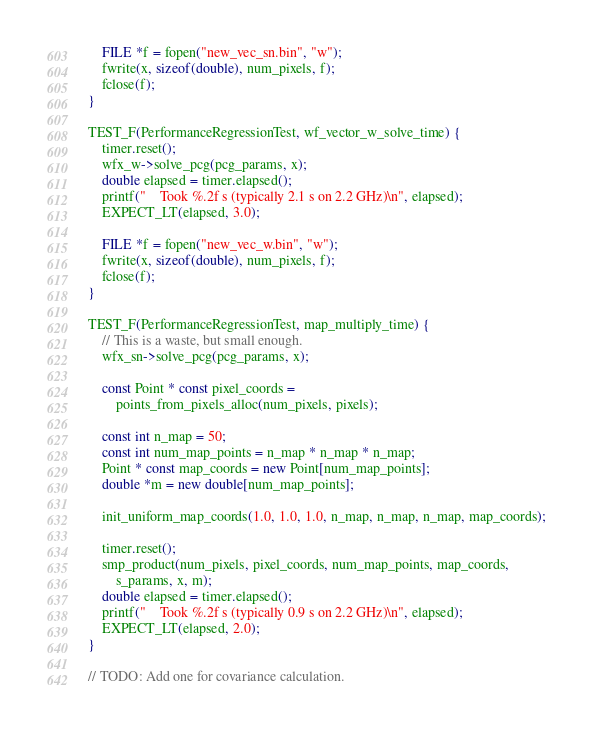<code> <loc_0><loc_0><loc_500><loc_500><_C++_>
    FILE *f = fopen("new_vec_sn.bin", "w");
    fwrite(x, sizeof(double), num_pixels, f);
    fclose(f);
}

TEST_F(PerformanceRegressionTest, wf_vector_w_solve_time) {
    timer.reset();
    wfx_w->solve_pcg(pcg_params, x);
    double elapsed = timer.elapsed();
    printf("    Took %.2f s (typically 2.1 s on 2.2 GHz)\n", elapsed);
    EXPECT_LT(elapsed, 3.0);

    FILE *f = fopen("new_vec_w.bin", "w");
    fwrite(x, sizeof(double), num_pixels, f);
    fclose(f);
}

TEST_F(PerformanceRegressionTest, map_multiply_time) {
    // This is a waste, but small enough.
    wfx_sn->solve_pcg(pcg_params, x);

    const Point * const pixel_coords =
        points_from_pixels_alloc(num_pixels, pixels);

    const int n_map = 50;
    const int num_map_points = n_map * n_map * n_map;
    Point * const map_coords = new Point[num_map_points];
    double *m = new double[num_map_points];

    init_uniform_map_coords(1.0, 1.0, 1.0, n_map, n_map, n_map, map_coords);

    timer.reset();
    smp_product(num_pixels, pixel_coords, num_map_points, map_coords,
        s_params, x, m);
    double elapsed = timer.elapsed();
    printf("    Took %.2f s (typically 0.9 s on 2.2 GHz)\n", elapsed);
    EXPECT_LT(elapsed, 2.0);
}

// TODO: Add one for covariance calculation.
</code> 